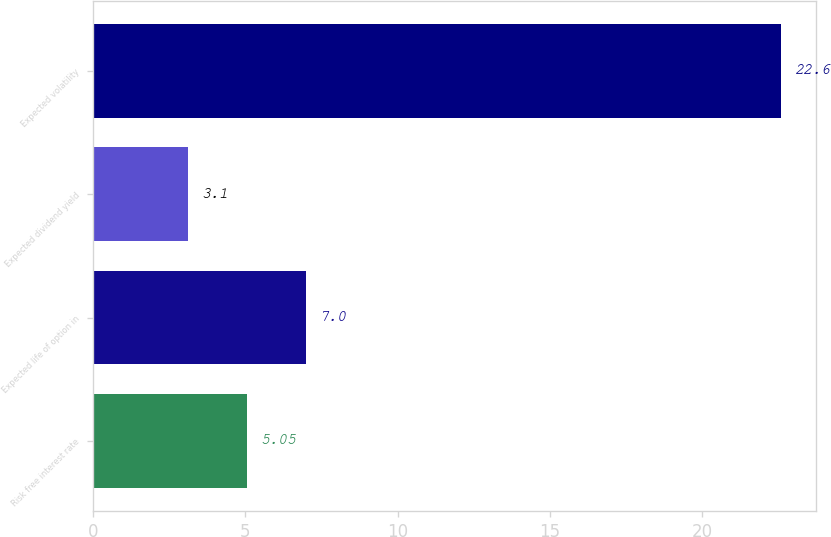<chart> <loc_0><loc_0><loc_500><loc_500><bar_chart><fcel>Risk free interest rate<fcel>Expected life of option in<fcel>Expected dividend yield<fcel>Expected volatility<nl><fcel>5.05<fcel>7<fcel>3.1<fcel>22.6<nl></chart> 